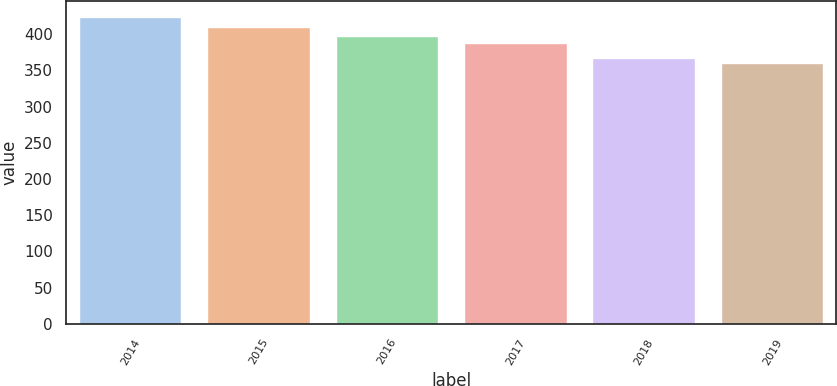Convert chart to OTSL. <chart><loc_0><loc_0><loc_500><loc_500><bar_chart><fcel>2014<fcel>2015<fcel>2016<fcel>2017<fcel>2018<fcel>2019<nl><fcel>424<fcel>410<fcel>397<fcel>387<fcel>367<fcel>360<nl></chart> 